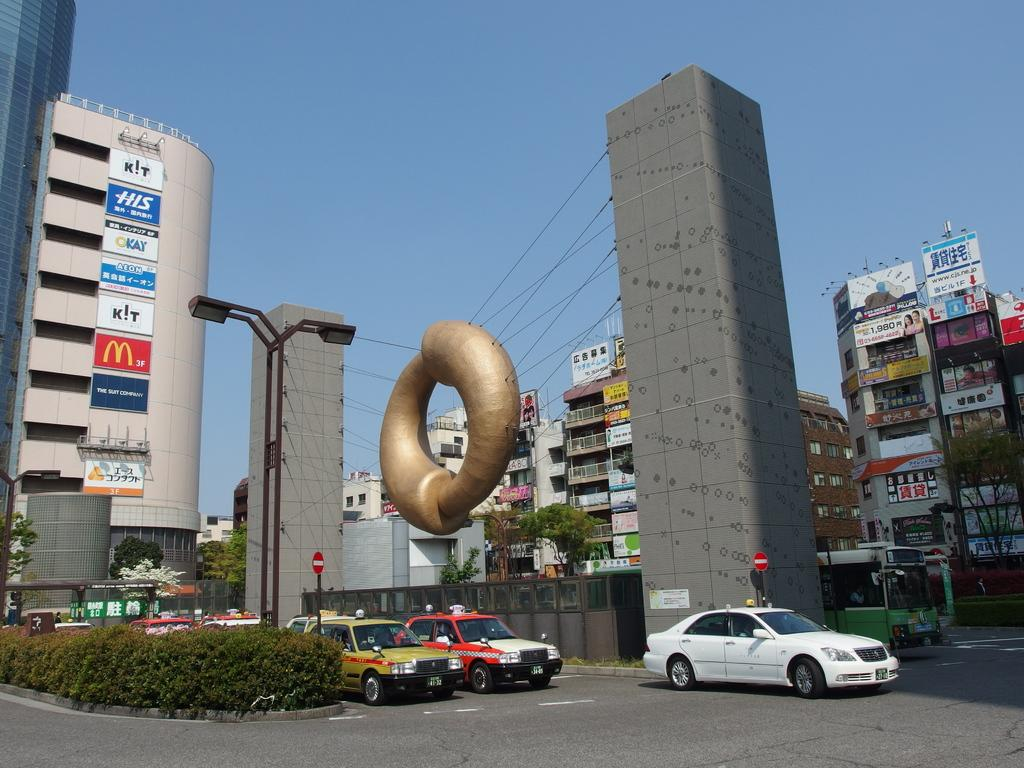<image>
Provide a brief description of the given image. A tall parking structure with ads from McDonald's and Kay on it. 